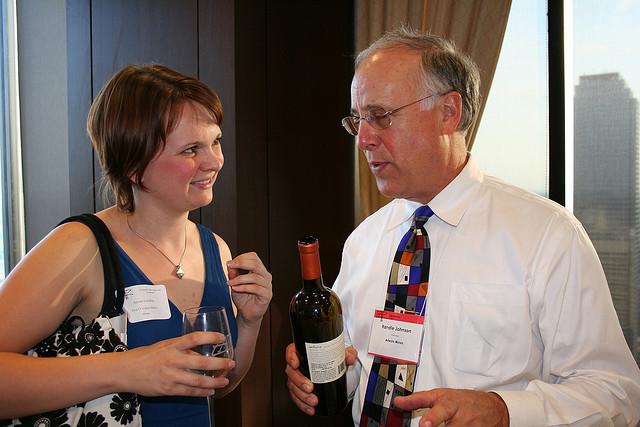Are they both drinking wine?
Be succinct. No. What accessory is in the woman's hair?
Short answer required. None. What is the man showing the woman?
Be succinct. Wine. What are they drinking?
Be succinct. Wine. How many pairs of glasses?
Short answer required. 1. How many name tags do you see?
Quick response, please. 2. Are they both men?
Short answer required. No. What restaurant logo is on the man's shirt in the middle?
Answer briefly. No logo. What kind of drink is the man holding?
Keep it brief. Wine. 